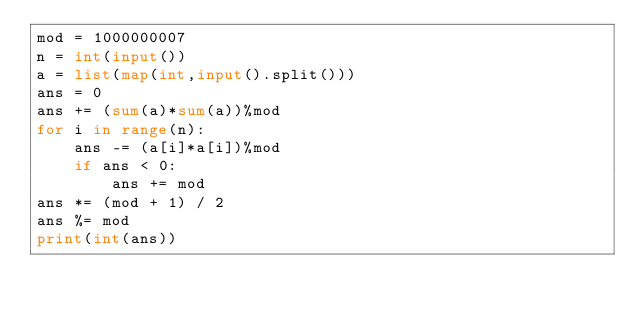Convert code to text. <code><loc_0><loc_0><loc_500><loc_500><_Python_>mod = 1000000007
n = int(input())
a = list(map(int,input().split()))
ans = 0
ans += (sum(a)*sum(a))%mod
for i in range(n):
    ans -= (a[i]*a[i])%mod
    if ans < 0:
        ans += mod
ans *= (mod + 1) / 2
ans %= mod
print(int(ans))</code> 